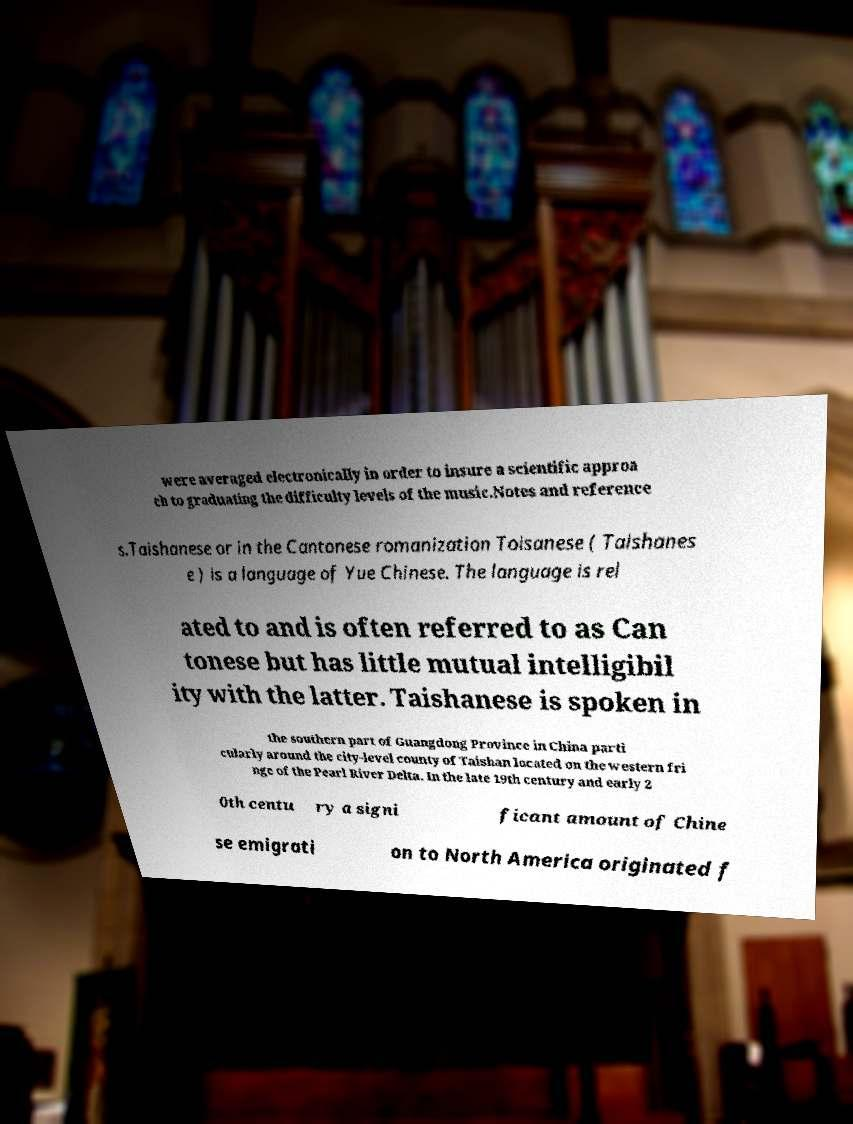Please read and relay the text visible in this image. What does it say? were averaged electronically in order to insure a scientific approa ch to graduating the difficulty levels of the music.Notes and reference s.Taishanese or in the Cantonese romanization Toisanese ( Taishanes e ) is a language of Yue Chinese. The language is rel ated to and is often referred to as Can tonese but has little mutual intelligibil ity with the latter. Taishanese is spoken in the southern part of Guangdong Province in China parti cularly around the city-level county of Taishan located on the western fri nge of the Pearl River Delta. In the late 19th century and early 2 0th centu ry a signi ficant amount of Chine se emigrati on to North America originated f 